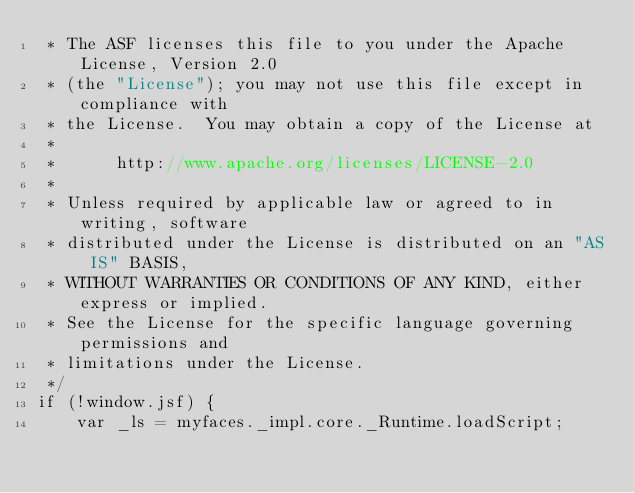Convert code to text. <code><loc_0><loc_0><loc_500><loc_500><_JavaScript_> * The ASF licenses this file to you under the Apache License, Version 2.0
 * (the "License"); you may not use this file except in compliance with
 * the License.  You may obtain a copy of the License at
 *
 *      http://www.apache.org/licenses/LICENSE-2.0
 *
 * Unless required by applicable law or agreed to in writing, software
 * distributed under the License is distributed on an "AS IS" BASIS,
 * WITHOUT WARRANTIES OR CONDITIONS OF ANY KIND, either express or implied.
 * See the License for the specific language governing permissions and
 * limitations under the License.
 */
if (!window.jsf) {
    var _ls = myfaces._impl.core._Runtime.loadScript;</code> 